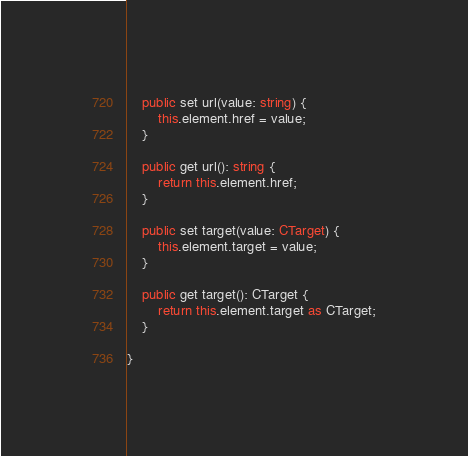Convert code to text. <code><loc_0><loc_0><loc_500><loc_500><_TypeScript_>
	public set url(value: string) {
		this.element.href = value;
	}

	public get url(): string {
		return this.element.href;
	}

	public set target(value: CTarget) {
		this.element.target = value;
	}

	public get target(): CTarget {
		return this.element.target as CTarget;
	}

}
</code> 